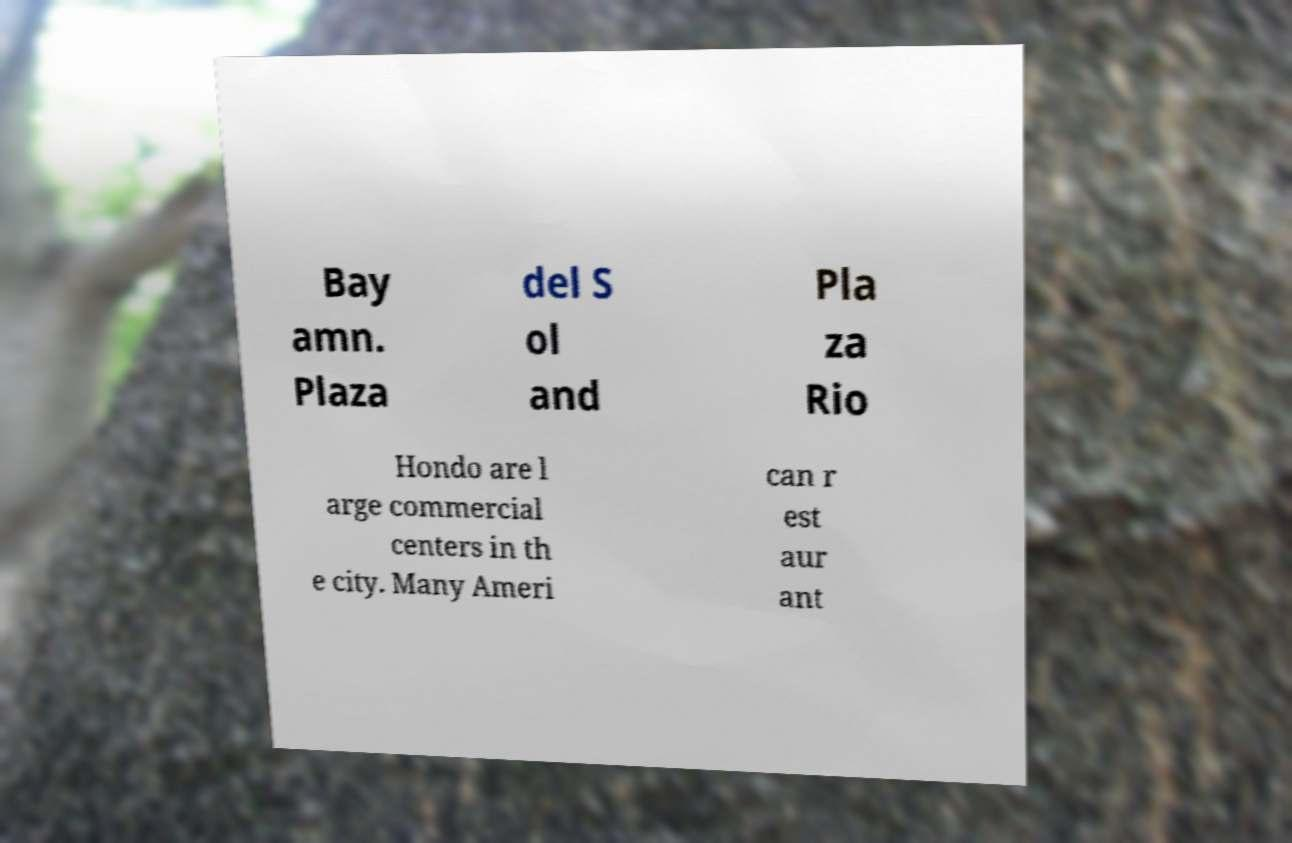There's text embedded in this image that I need extracted. Can you transcribe it verbatim? Bay amn. Plaza del S ol and Pla za Rio Hondo are l arge commercial centers in th e city. Many Ameri can r est aur ant 